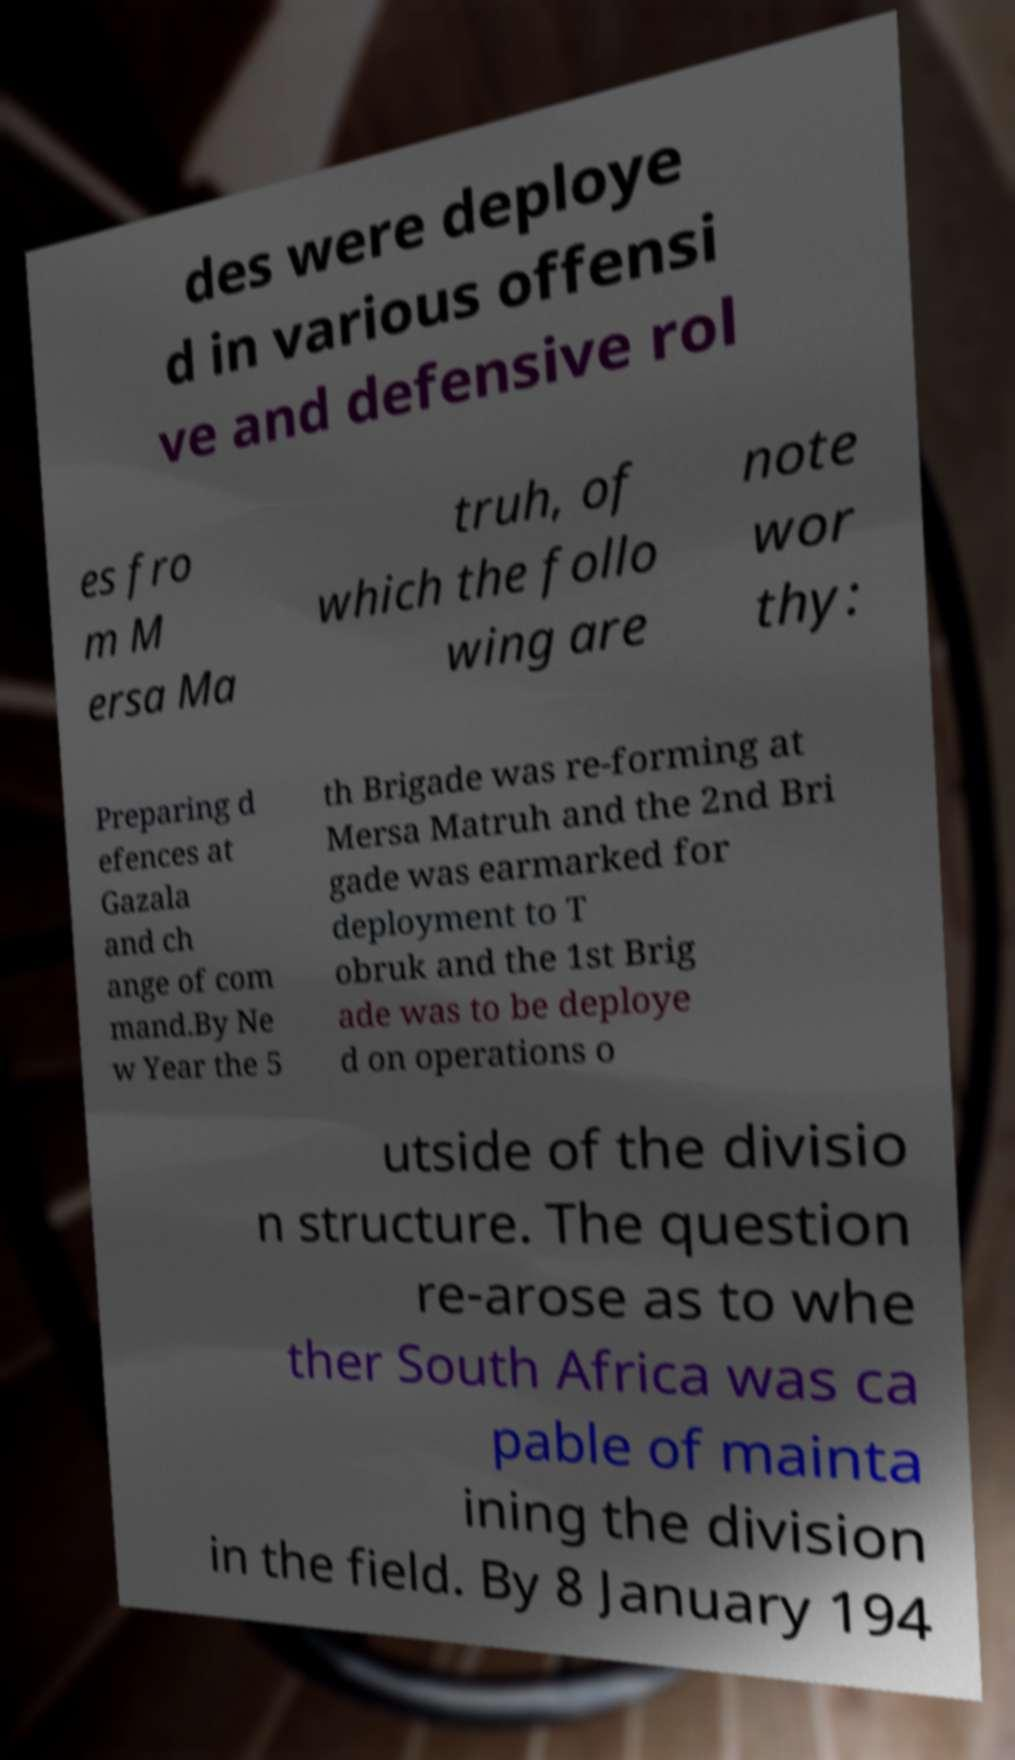There's text embedded in this image that I need extracted. Can you transcribe it verbatim? des were deploye d in various offensi ve and defensive rol es fro m M ersa Ma truh, of which the follo wing are note wor thy: Preparing d efences at Gazala and ch ange of com mand.By Ne w Year the 5 th Brigade was re-forming at Mersa Matruh and the 2nd Bri gade was earmarked for deployment to T obruk and the 1st Brig ade was to be deploye d on operations o utside of the divisio n structure. The question re-arose as to whe ther South Africa was ca pable of mainta ining the division in the field. By 8 January 194 